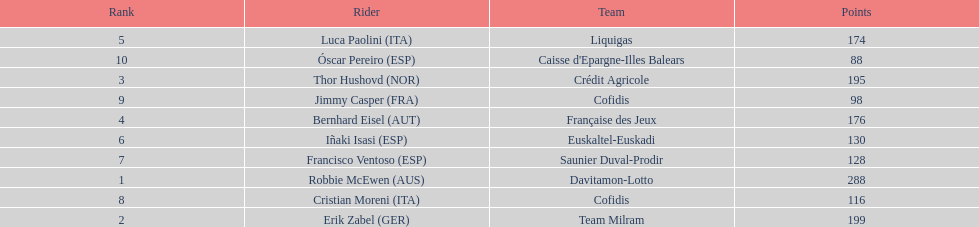How many points did robbie mcewen and cristian moreni score together? 404. 